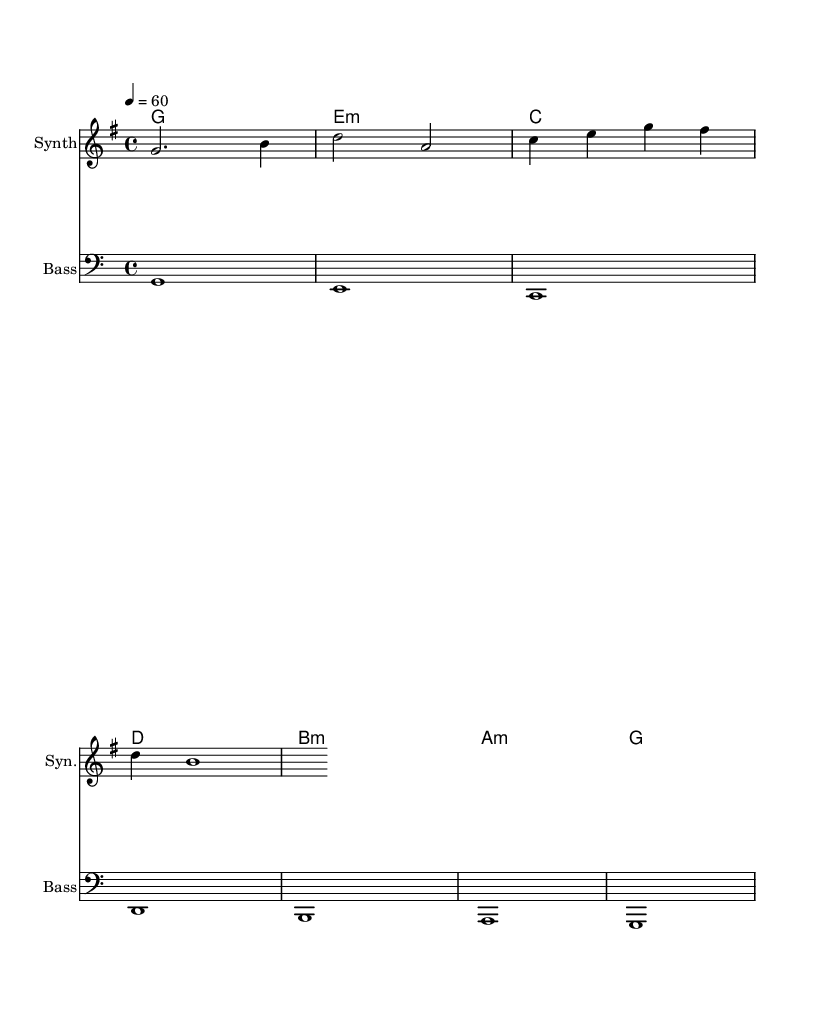What is the key signature of this music? The key signature indicated at the beginning is G major, which has one sharp.
Answer: G major What is the time signature of this music? The time signature shown in the sheet music is 4/4, meaning there are four beats per measure and the quarter note gets one beat.
Answer: 4/4 What is the tempo marking for this piece? The tempo marking is indicated as 4 = 60, meaning that the quarter note should be played at a speed of 60 beats per minute.
Answer: 60 How many measures are in the melody? By counting the distinct lines and measures in the melody section, there are four measures.
Answer: 4 What harmonic progression is used in the piece? The harmonic progression, as indicated in the chord mode, follows the progression of G, E minor, C, D, B minor, A minor, and G.
Answer: G, E minor, C, D, B minor, A minor, G Which clef is used for the bass line? The bass line is written in the bass clef, which is typically used for lower-pitched instruments or voices.
Answer: Bass clef What type of electronic instrument is used for the melody? The melody is played on a synth, which is a common type of electronic instrument used to create ambient sounds.
Answer: Synth 